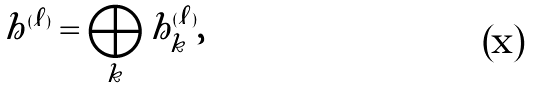<formula> <loc_0><loc_0><loc_500><loc_500>h ^ { ( \ell ) } = \bigoplus _ { k } h _ { k } ^ { ( \ell ) } ,</formula> 